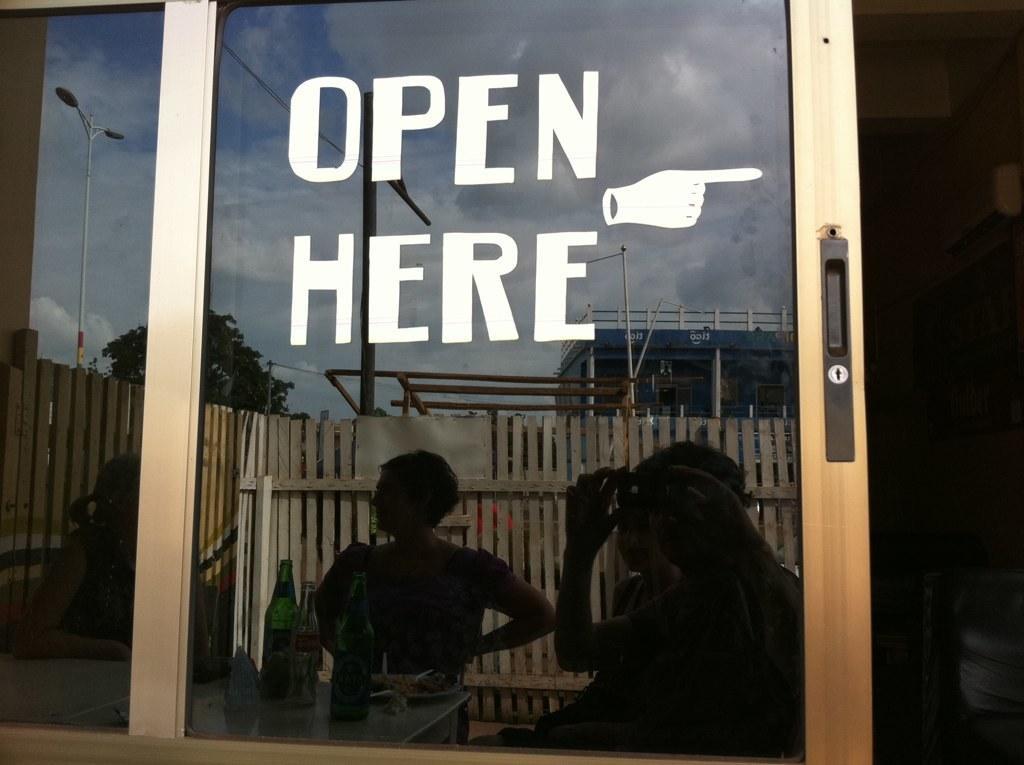Please provide a concise description of this image. In this image in the foreground there is a glass door. On it "OPEN HERE " is written. On the glass there is reflection of few people. On a table there are few bottles and plate. In the background there are boundary, trees and building. Here there is a street light. 